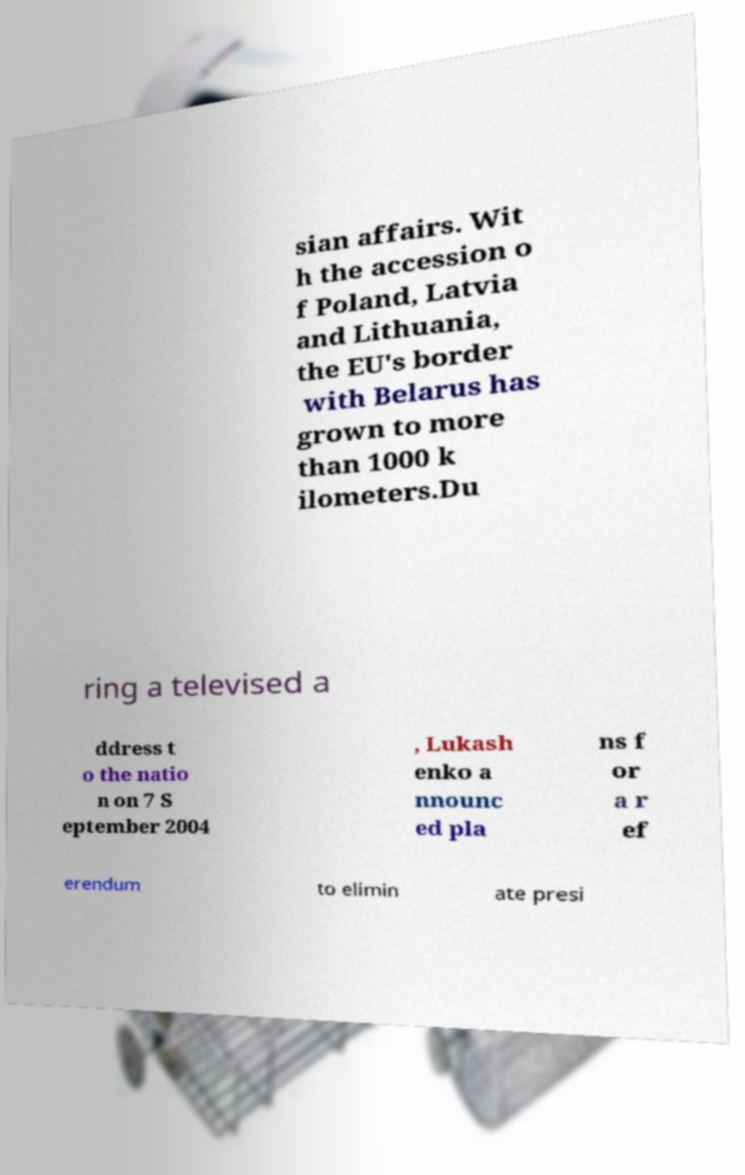Can you accurately transcribe the text from the provided image for me? sian affairs. Wit h the accession o f Poland, Latvia and Lithuania, the EU's border with Belarus has grown to more than 1000 k ilometers.Du ring a televised a ddress t o the natio n on 7 S eptember 2004 , Lukash enko a nnounc ed pla ns f or a r ef erendum to elimin ate presi 